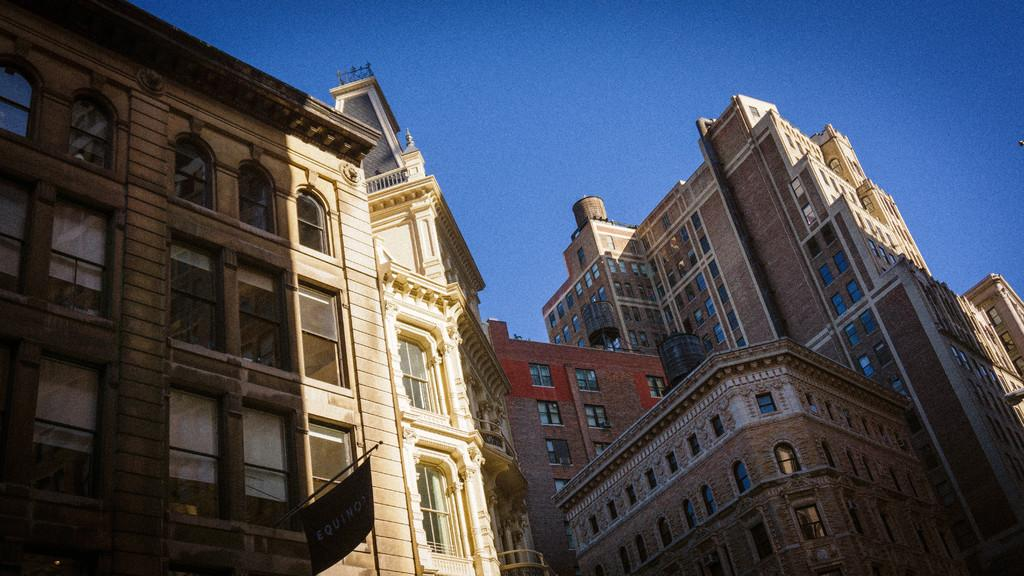What type of structures can be seen in the image? There are buildings in the image. What feature is visible on the buildings? There are windows visible on the buildings. What object is present in the image besides the buildings? There is a board in the image. What can be seen in the background of the image? The sky is visible in the background of the image. Can you tell me what type of harmony is being played in the image? There is no indication of music or harmony in the image; it features buildings, windows, a board, and the sky. Is there a receipt visible in the image? There is no receipt present in the image. 